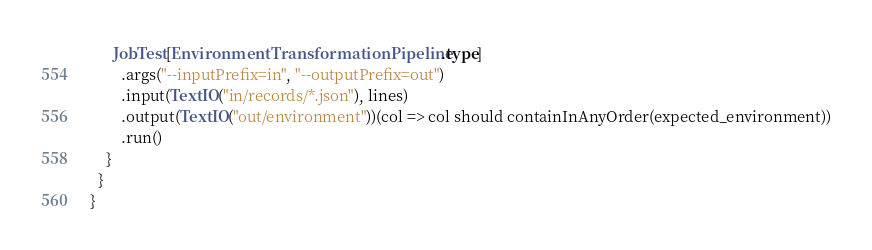<code> <loc_0><loc_0><loc_500><loc_500><_Scala_>      JobTest[EnvironmentTransformationPipeline.type]
        .args("--inputPrefix=in", "--outputPrefix=out")
        .input(TextIO("in/records/*.json"), lines)
        .output(TextIO("out/environment"))(col => col should containInAnyOrder(expected_environment))
        .run()
    }
  }
}
</code> 